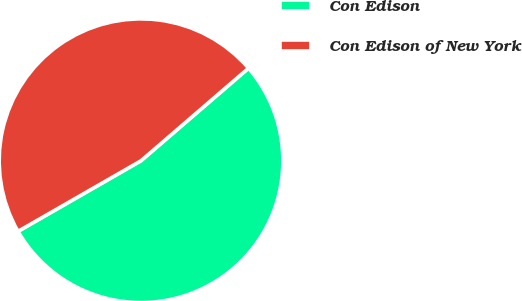Convert chart to OTSL. <chart><loc_0><loc_0><loc_500><loc_500><pie_chart><fcel>Con Edison<fcel>Con Edison of New York<nl><fcel>53.02%<fcel>46.98%<nl></chart> 